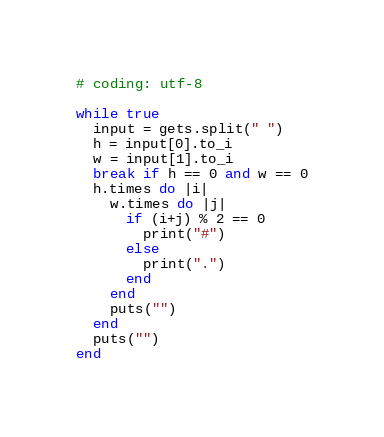Convert code to text. <code><loc_0><loc_0><loc_500><loc_500><_Ruby_># coding: utf-8

while true
  input = gets.split(" ")
  h = input[0].to_i
  w = input[1].to_i
  break if h == 0 and w == 0
  h.times do |i|
    w.times do |j|
      if (i+j) % 2 == 0 
        print("#")
      else
        print(".")
      end
    end
    puts("")
  end
  puts("")
end</code> 